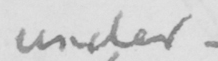Please transcribe the handwritten text in this image. under 